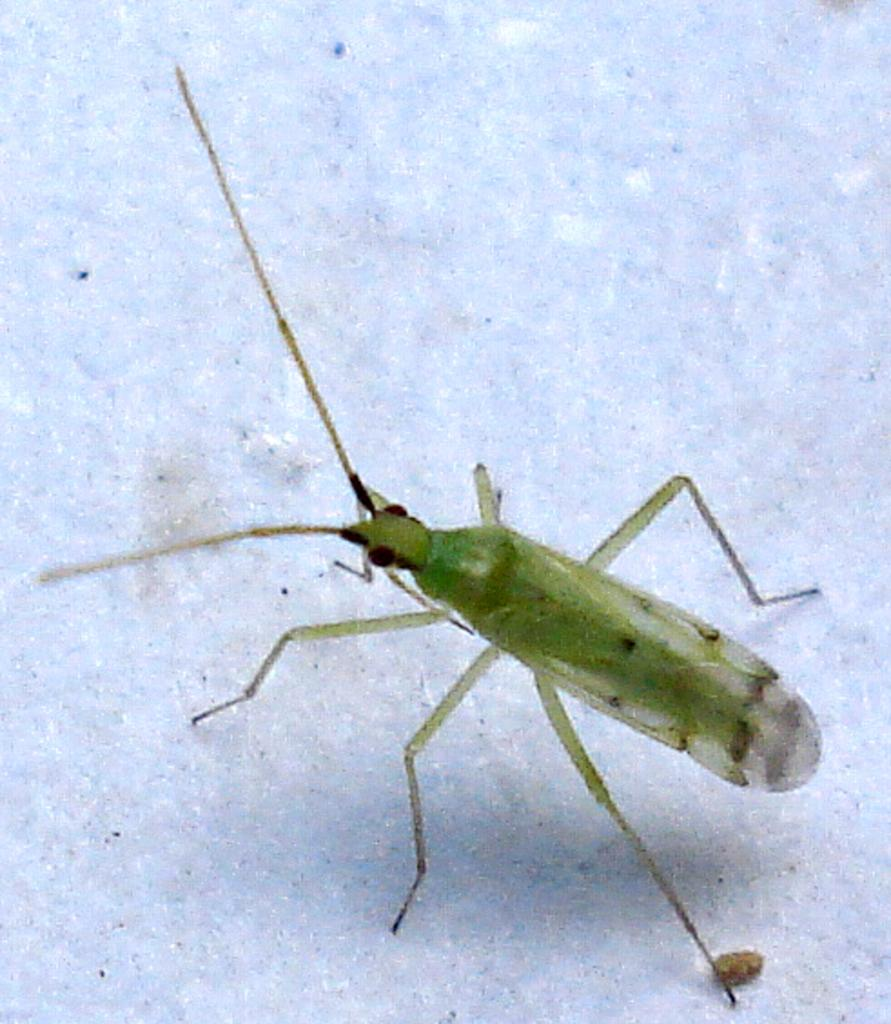What type of creature can be seen in the image? There is an insect in the image. Where is the insect located in the image? The insect is on a surface. What type of seat is visible in the image? There is no seat present in the image; it only features an insect on a surface. In which direction is the insect facing in the image? The provided facts do not indicate the direction the insect is facing, as it only mentions the insect's presence on a surface. 